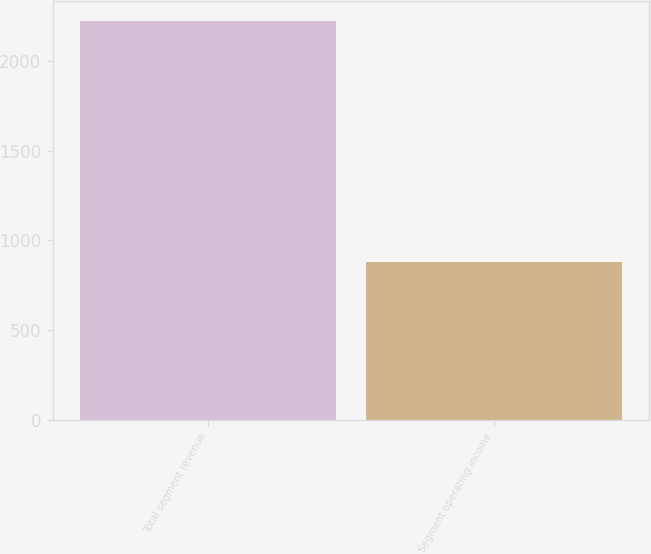Convert chart. <chart><loc_0><loc_0><loc_500><loc_500><bar_chart><fcel>Total segment revenue<fcel>Segment operating income<nl><fcel>2221<fcel>879<nl></chart> 